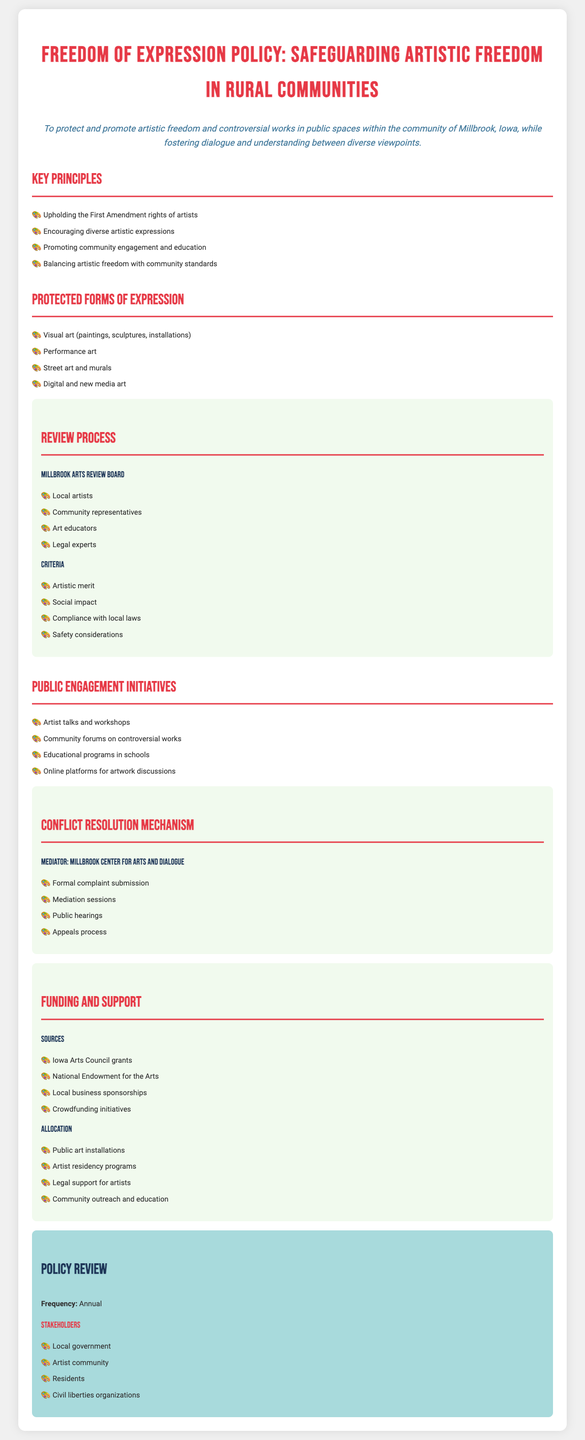What is the title of the policy document? The title of the policy document is presented at the top of the document.
Answer: Freedom of Expression Policy: Safeguarding Artistic Freedom in Rural Communities What is the objective of the policy? The objective is explicitly stated in a dedicated section, highlighting the aims of the policy.
Answer: To protect and promote artistic freedom and controversial works in public spaces within the community of Millbrook, Iowa, while fostering dialogue and understanding between diverse viewpoints Who is involved in the review process? A section outlines the members of the Millbrook Arts Review Board, specifying who is included.
Answer: Local artists, Community representatives, Art educators, Legal experts What is one form of expression protected by the policy? The document lists various forms of expression, of which one example can be provided.
Answer: Visual art (paintings, sculptures, installations) What are the sources of funding mentioned? The policy lists specific funding sources available to support artistic freedom.
Answer: Iowa Arts Council grants, National Endowment for the Arts, Local business sponsorships, Crowdfunding initiatives How often is the policy reviewed? The frequency of the policy review is explicitly mentioned in the document.
Answer: Annual What mechanism is established for conflict resolution? A section details the conflict resolution mechanism in place related to this policy.
Answer: Mediator: Millbrook Center for Arts and Dialogue What is a key principle of the policy? The document lists key principles that guide the overall aim of the policy.
Answer: Upholding the First Amendment rights of artists How many community engagement initiatives are listed? The document outlines various initiatives related to public engagement, referencing how many are mentioned.
Answer: Four 